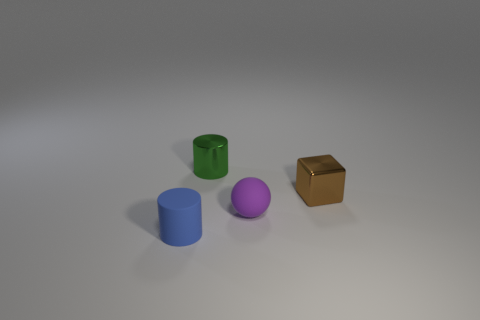Are there any red shiny cubes that have the same size as the rubber cylinder?
Provide a succinct answer. No. What material is the green cylinder that is the same size as the purple object?
Ensure brevity in your answer.  Metal. How many metal things are either small gray blocks or brown cubes?
Your response must be concise. 1. How many tiny purple objects have the same shape as the tiny blue matte thing?
Your answer should be very brief. 0. What shape is the small matte thing on the right side of the small rubber cylinder?
Your answer should be compact. Sphere. What is the material of the green thing that is the same shape as the blue matte object?
Offer a very short reply. Metal. What number of tiny green cylinders are left of the purple rubber sphere?
Your response must be concise. 1. Are there fewer purple rubber spheres behind the brown thing than purple things behind the rubber cylinder?
Provide a short and direct response. Yes. How many small metal objects are there?
Provide a short and direct response. 2. What color is the tiny cylinder in front of the purple thing?
Offer a very short reply. Blue. 